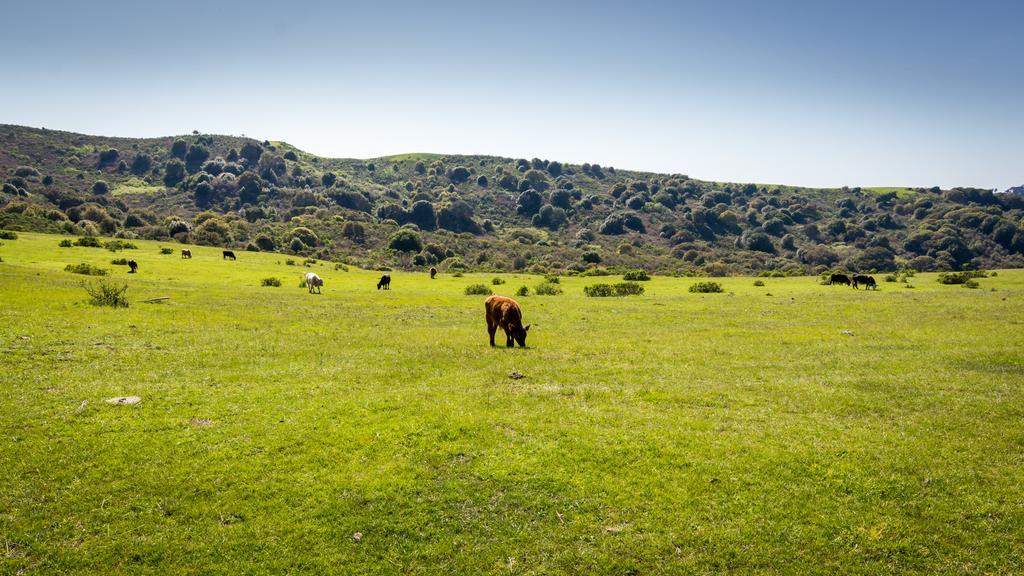How would you summarize this image in a sentence or two? In this picture I can see few animals are grazing in the middle. In the background there are trees, at the top there is the sky. 